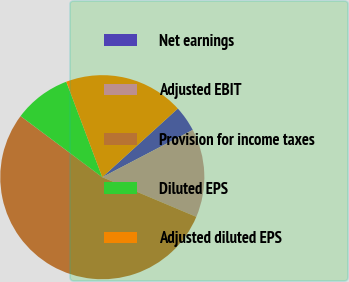Convert chart to OTSL. <chart><loc_0><loc_0><loc_500><loc_500><pie_chart><fcel>Net earnings<fcel>Adjusted EBIT<fcel>Provision for income taxes<fcel>Diluted EPS<fcel>Adjusted diluted EPS<nl><fcel>4.07%<fcel>14.02%<fcel>53.86%<fcel>9.04%<fcel>19.0%<nl></chart> 